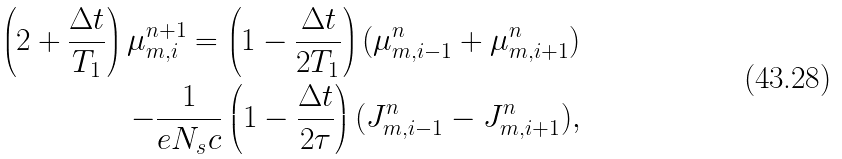Convert formula to latex. <formula><loc_0><loc_0><loc_500><loc_500>\left ( 2 + \frac { \Delta { t } } { T _ { 1 } } \right ) \mu _ { m , i } ^ { n + 1 } = \left ( 1 - \frac { \Delta { t } } { 2 T _ { 1 } } \right ) ( \mu _ { m , i - 1 } ^ { n } + \mu _ { m , i + 1 } ^ { n } ) \\ - \frac { 1 } { e N _ { s } c } \left ( 1 - \frac { \Delta t } { 2 \tau } \right ) ( J _ { m , i - 1 } ^ { n } - J _ { m , i + 1 } ^ { n } ) ,</formula> 